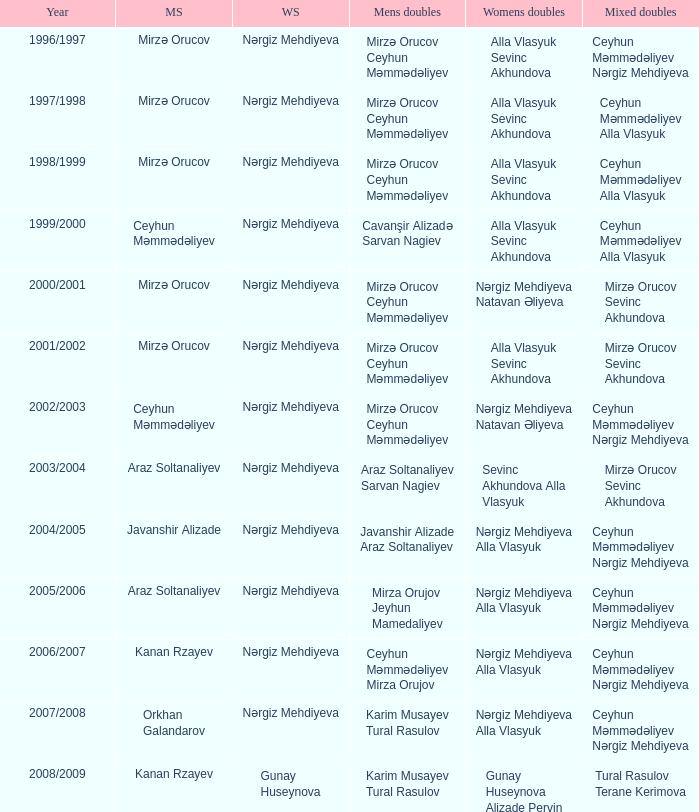What are all values for Womens Doubles in the year 2000/2001? Nərgiz Mehdiyeva Natavan Əliyeva. 